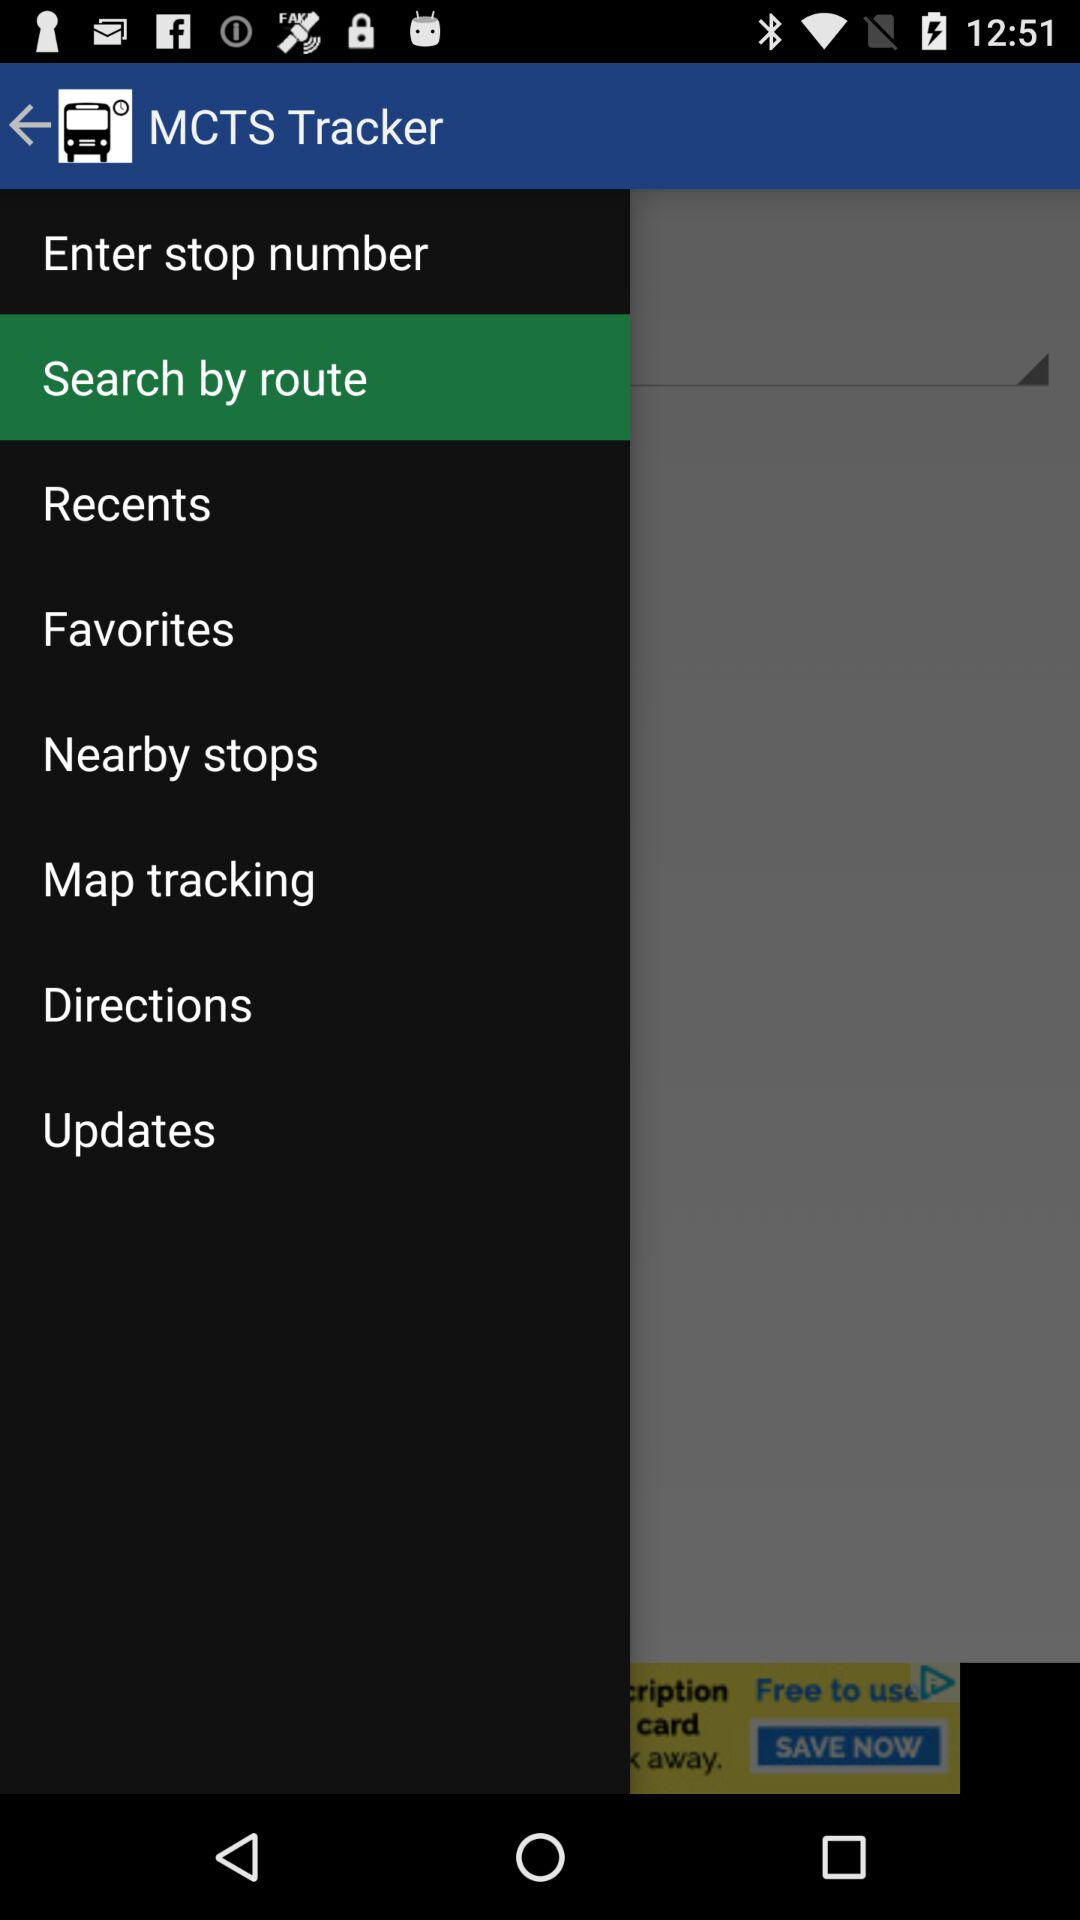What are the options available? The available options are "Enter stop number", "Search by route", "Recents", "Favorites", "Nearby stops", "Map tracking", "Directions" and "Updates". 